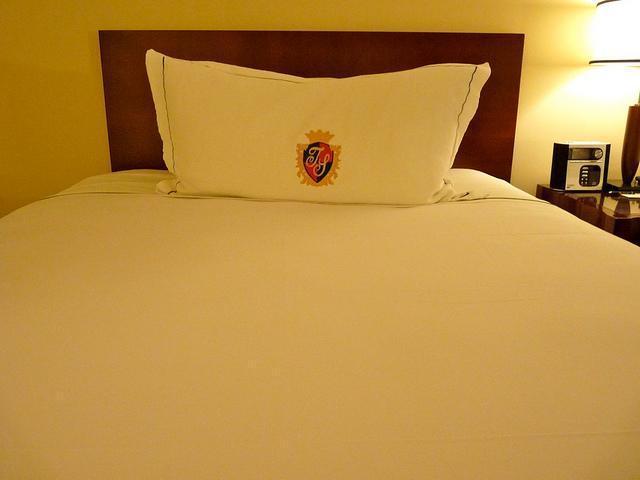How many people are lifting bags of bananas?
Give a very brief answer. 0. 